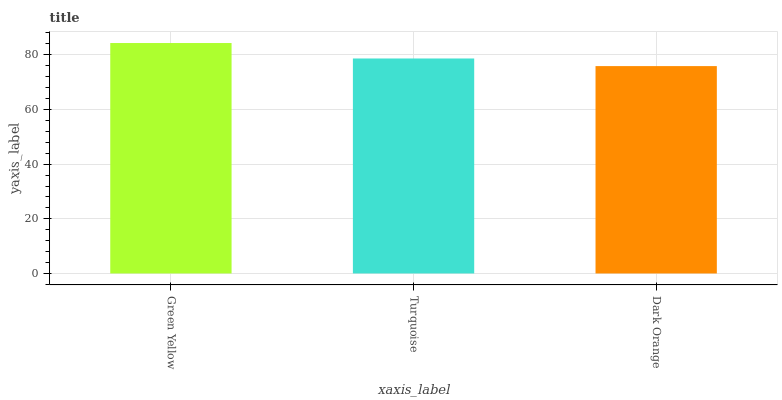Is Dark Orange the minimum?
Answer yes or no. Yes. Is Green Yellow the maximum?
Answer yes or no. Yes. Is Turquoise the minimum?
Answer yes or no. No. Is Turquoise the maximum?
Answer yes or no. No. Is Green Yellow greater than Turquoise?
Answer yes or no. Yes. Is Turquoise less than Green Yellow?
Answer yes or no. Yes. Is Turquoise greater than Green Yellow?
Answer yes or no. No. Is Green Yellow less than Turquoise?
Answer yes or no. No. Is Turquoise the high median?
Answer yes or no. Yes. Is Turquoise the low median?
Answer yes or no. Yes. Is Dark Orange the high median?
Answer yes or no. No. Is Dark Orange the low median?
Answer yes or no. No. 